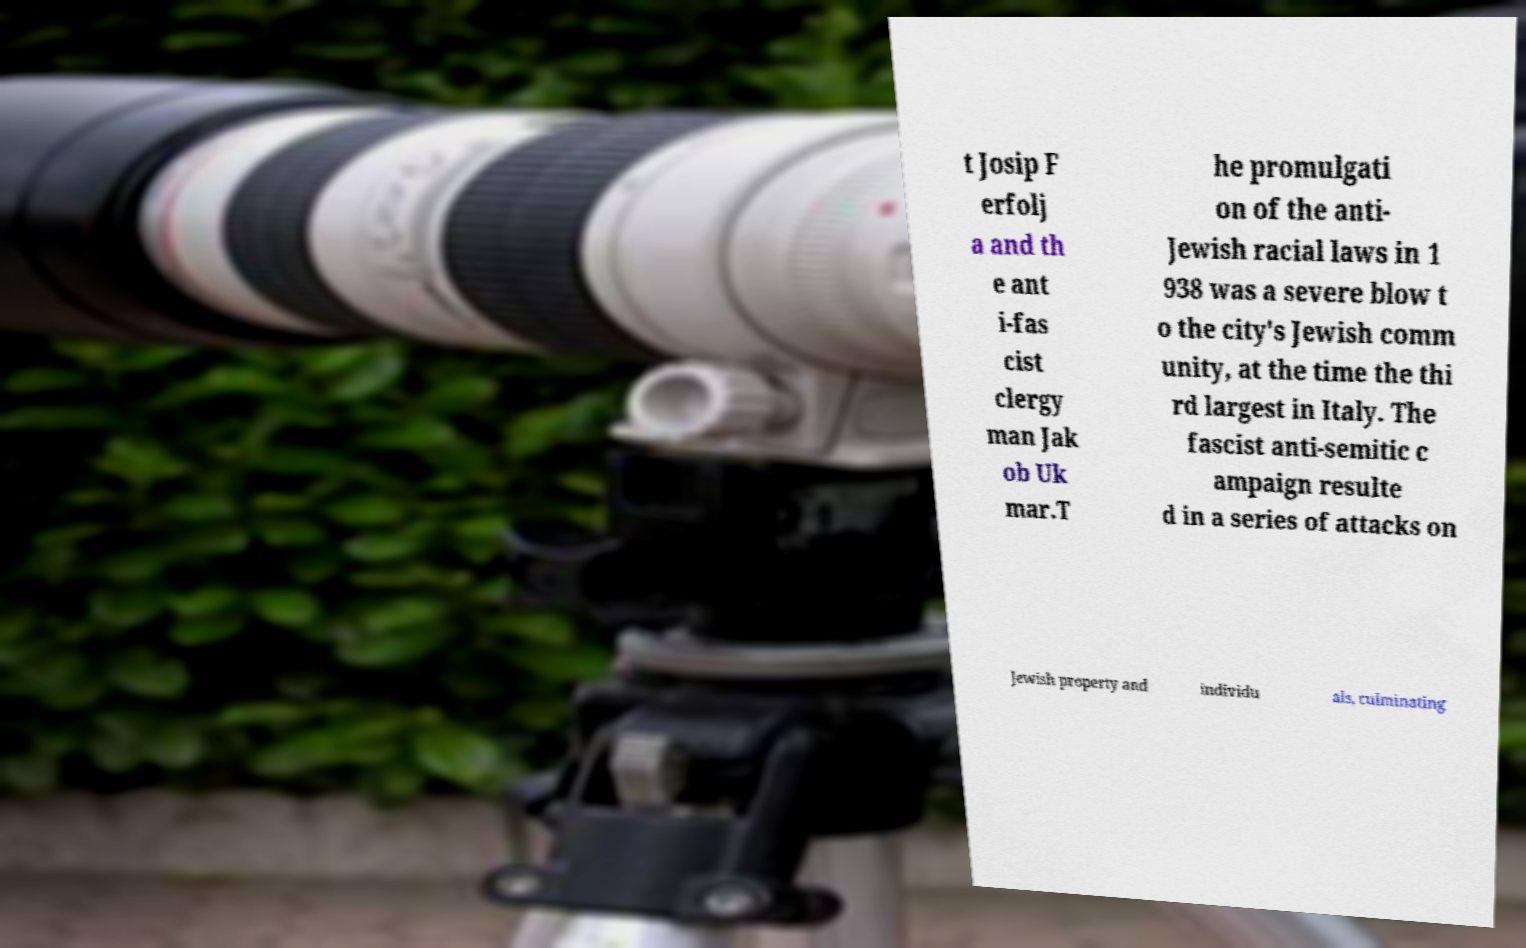Can you accurately transcribe the text from the provided image for me? t Josip F erfolj a and th e ant i-fas cist clergy man Jak ob Uk mar.T he promulgati on of the anti- Jewish racial laws in 1 938 was a severe blow t o the city's Jewish comm unity, at the time the thi rd largest in Italy. The fascist anti-semitic c ampaign resulte d in a series of attacks on Jewish property and individu als, culminating 